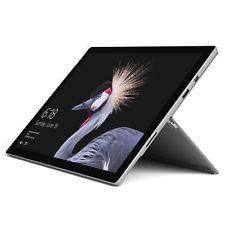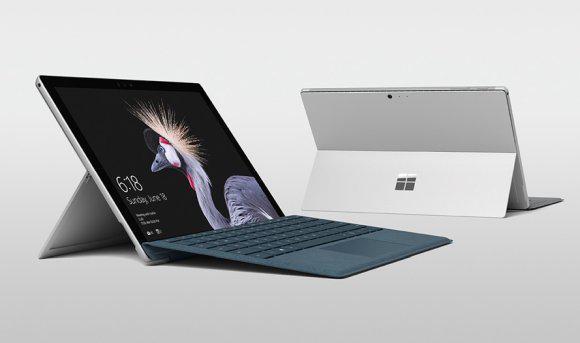The first image is the image on the left, the second image is the image on the right. Evaluate the accuracy of this statement regarding the images: "there is a stylus on the table next to a laptop". Is it true? Answer yes or no. No. The first image is the image on the left, the second image is the image on the right. Given the left and right images, does the statement "There are no more than 2 stylus's sitting next to laptops." hold true? Answer yes or no. No. 